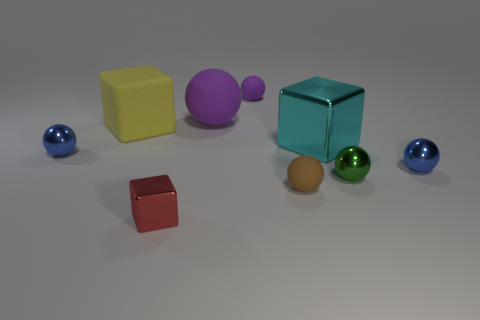Do the small blue object that is right of the small purple sphere and the small thing that is behind the yellow block have the same material?
Provide a succinct answer. No. Is the number of brown spheres behind the tiny purple matte thing less than the number of big green matte cylinders?
Provide a short and direct response. No. Are there any other things that have the same shape as the cyan thing?
Offer a very short reply. Yes. The big rubber thing that is the same shape as the tiny brown rubber thing is what color?
Your response must be concise. Purple. Does the metallic ball that is to the left of the red cube have the same size as the tiny purple matte ball?
Give a very brief answer. Yes. There is a blue thing on the left side of the matte sphere that is in front of the tiny green shiny sphere; what size is it?
Your answer should be compact. Small. Does the green object have the same material as the blue object that is to the left of the large matte sphere?
Your answer should be compact. Yes. Are there fewer big blocks that are left of the large yellow block than blue spheres that are right of the cyan metal thing?
Your answer should be very brief. Yes. The cube that is the same material as the big purple sphere is what color?
Offer a terse response. Yellow. There is a tiny metallic ball that is on the left side of the red thing; are there any small metallic objects left of it?
Provide a short and direct response. No. 